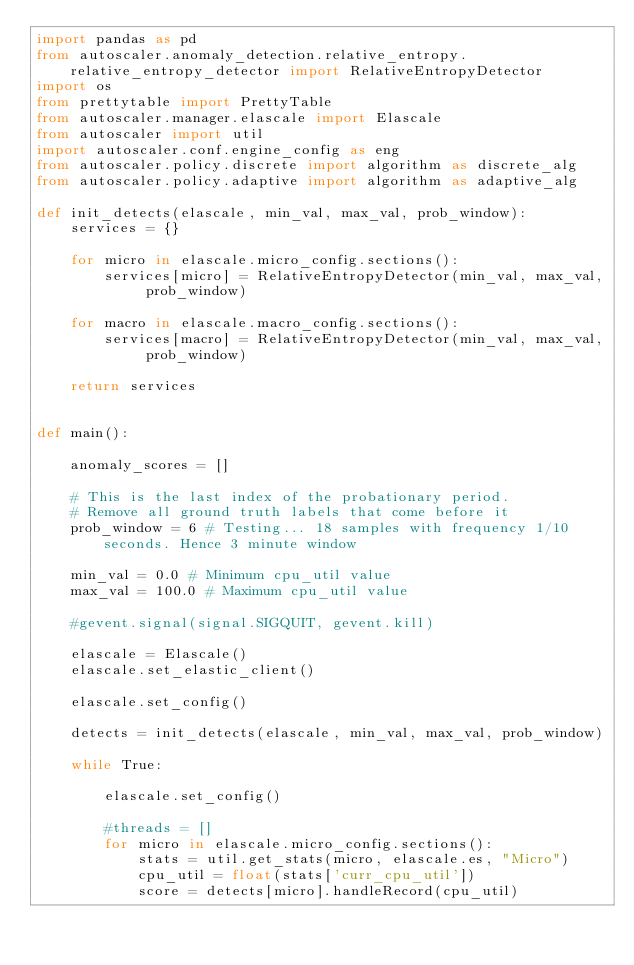Convert code to text. <code><loc_0><loc_0><loc_500><loc_500><_Python_>import pandas as pd
from autoscaler.anomaly_detection.relative_entropy.relative_entropy_detector import RelativeEntropyDetector
import os
from prettytable import PrettyTable
from autoscaler.manager.elascale import Elascale
from autoscaler import util
import autoscaler.conf.engine_config as eng
from autoscaler.policy.discrete import algorithm as discrete_alg
from autoscaler.policy.adaptive import algorithm as adaptive_alg

def init_detects(elascale, min_val, max_val, prob_window):
    services = {}

    for micro in elascale.micro_config.sections():
        services[micro] = RelativeEntropyDetector(min_val, max_val, prob_window)

    for macro in elascale.macro_config.sections():
        services[macro] = RelativeEntropyDetector(min_val, max_val, prob_window)

    return services


def main():

    anomaly_scores = []

    # This is the last index of the probationary period.
    # Remove all ground truth labels that come before it
    prob_window = 6 # Testing... 18 samples with frequency 1/10 seconds. Hence 3 minute window

    min_val = 0.0 # Minimum cpu_util value
    max_val = 100.0 # Maximum cpu_util value

    #gevent.signal(signal.SIGQUIT, gevent.kill)

    elascale = Elascale()
    elascale.set_elastic_client()

    elascale.set_config()

    detects = init_detects(elascale, min_val, max_val, prob_window)

    while True:

        elascale.set_config()

        #threads = []
        for micro in elascale.micro_config.sections():
            stats = util.get_stats(micro, elascale.es, "Micro")
            cpu_util = float(stats['curr_cpu_util'])
            score = detects[micro].handleRecord(cpu_util)
</code> 